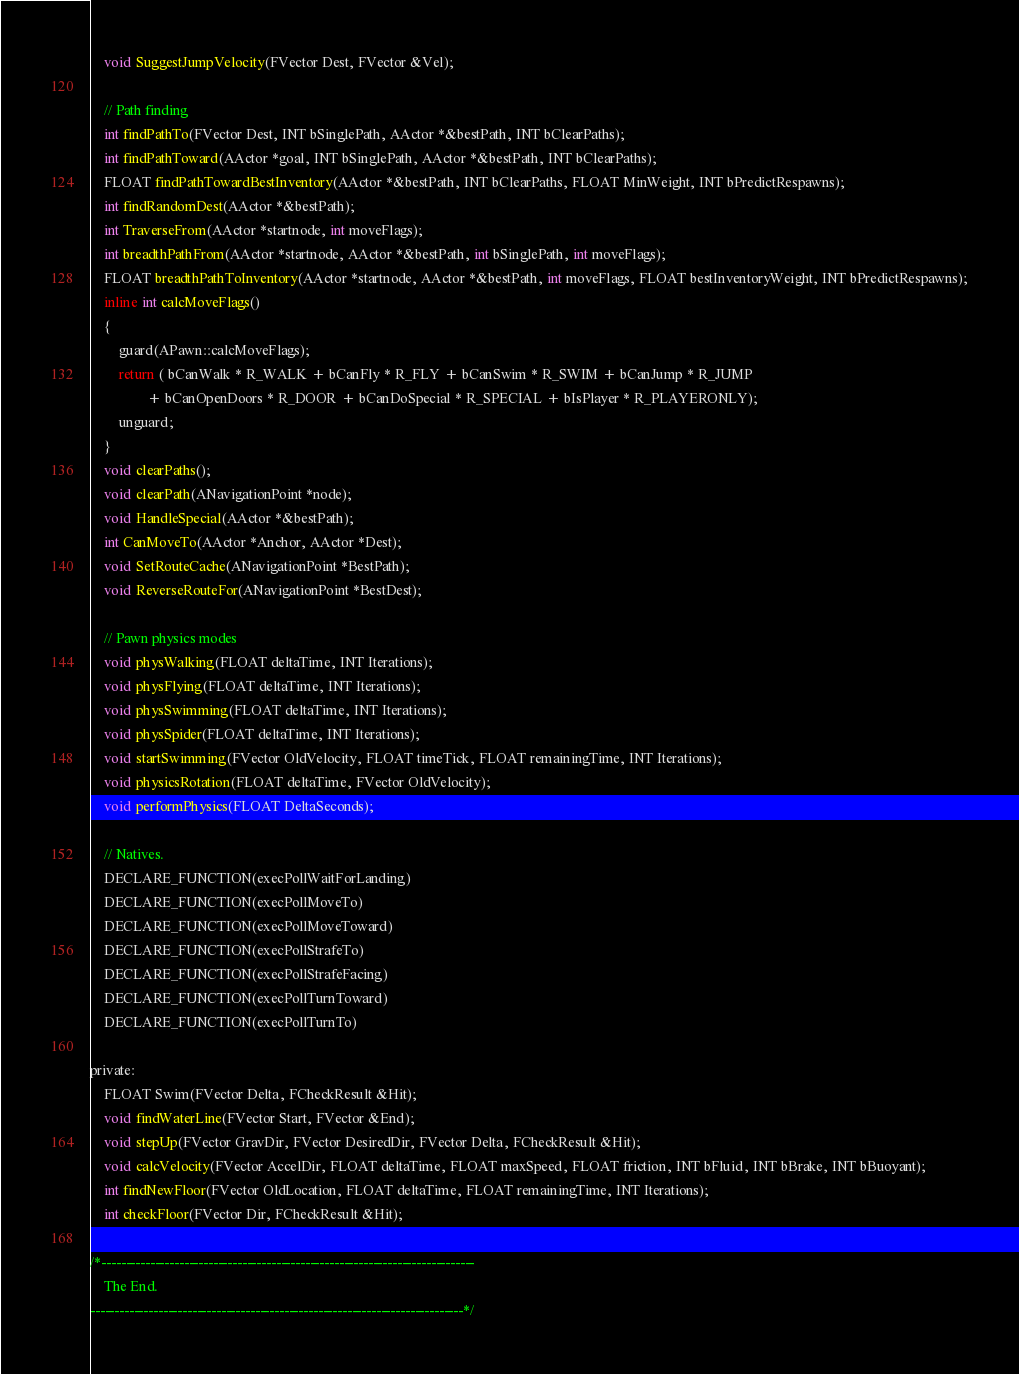Convert code to text. <code><loc_0><loc_0><loc_500><loc_500><_C_>	void SuggestJumpVelocity(FVector Dest, FVector &Vel);

	// Path finding
	int findPathTo(FVector Dest, INT bSinglePath, AActor *&bestPath, INT bClearPaths);
	int findPathToward(AActor *goal, INT bSinglePath, AActor *&bestPath, INT bClearPaths);
	FLOAT findPathTowardBestInventory(AActor *&bestPath, INT bClearPaths, FLOAT MinWeight, INT bPredictRespawns);
	int findRandomDest(AActor *&bestPath);
	int TraverseFrom(AActor *startnode, int moveFlags);
	int breadthPathFrom(AActor *startnode, AActor *&bestPath, int bSinglePath, int moveFlags);
	FLOAT breadthPathToInventory(AActor *startnode, AActor *&bestPath, int moveFlags, FLOAT bestInventoryWeight, INT bPredictRespawns);
	inline int calcMoveFlags()
	{
		guard(APawn::calcMoveFlags);
		return ( bCanWalk * R_WALK + bCanFly * R_FLY + bCanSwim * R_SWIM + bCanJump * R_JUMP 
				+ bCanOpenDoors * R_DOOR + bCanDoSpecial * R_SPECIAL + bIsPlayer * R_PLAYERONLY); 
		unguard;
	}
	void clearPaths();
	void clearPath(ANavigationPoint *node);
	void HandleSpecial(AActor *&bestPath);
	int CanMoveTo(AActor *Anchor, AActor *Dest);
	void SetRouteCache(ANavigationPoint *BestPath);
	void ReverseRouteFor(ANavigationPoint *BestDest);

	// Pawn physics modes
	void physWalking(FLOAT deltaTime, INT Iterations);
	void physFlying(FLOAT deltaTime, INT Iterations);
	void physSwimming(FLOAT deltaTime, INT Iterations);
	void physSpider(FLOAT deltaTime, INT Iterations);
	void startSwimming(FVector OldVelocity, FLOAT timeTick, FLOAT remainingTime, INT Iterations);
	void physicsRotation(FLOAT deltaTime, FVector OldVelocity);
	void performPhysics(FLOAT DeltaSeconds);

	// Natives.
	DECLARE_FUNCTION(execPollWaitForLanding)
	DECLARE_FUNCTION(execPollMoveTo)
	DECLARE_FUNCTION(execPollMoveToward)
	DECLARE_FUNCTION(execPollStrafeTo)
	DECLARE_FUNCTION(execPollStrafeFacing)
	DECLARE_FUNCTION(execPollTurnToward)
	DECLARE_FUNCTION(execPollTurnTo)

private:
	FLOAT Swim(FVector Delta, FCheckResult &Hit); 
	void findWaterLine(FVector Start, FVector &End);
	void stepUp(FVector GravDir, FVector DesiredDir, FVector Delta, FCheckResult &Hit);
	void calcVelocity(FVector AccelDir, FLOAT deltaTime, FLOAT maxSpeed, FLOAT friction, INT bFluid, INT bBrake, INT bBuoyant);
	int findNewFloor(FVector OldLocation, FLOAT deltaTime, FLOAT remainingTime, INT Iterations);
	int checkFloor(FVector Dir, FCheckResult &Hit);

/*-----------------------------------------------------------------------------
	The End.
-----------------------------------------------------------------------------*/
</code> 